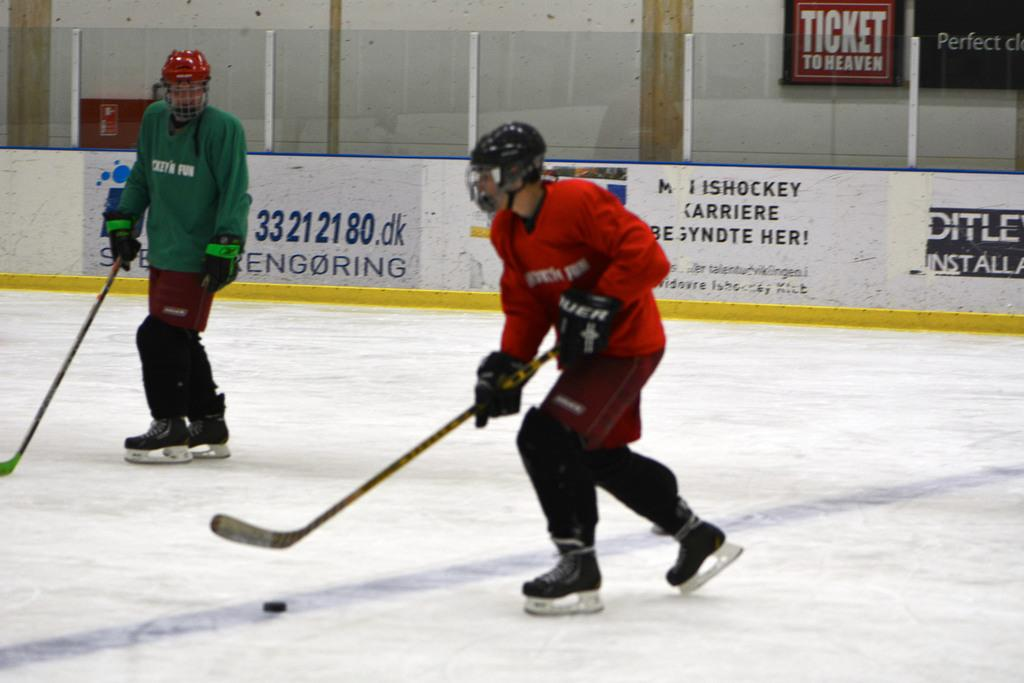<image>
Share a concise interpretation of the image provided. A hockey player in a red uniform has the puck with a sign that reads Ticket to heaven in the background wall. 